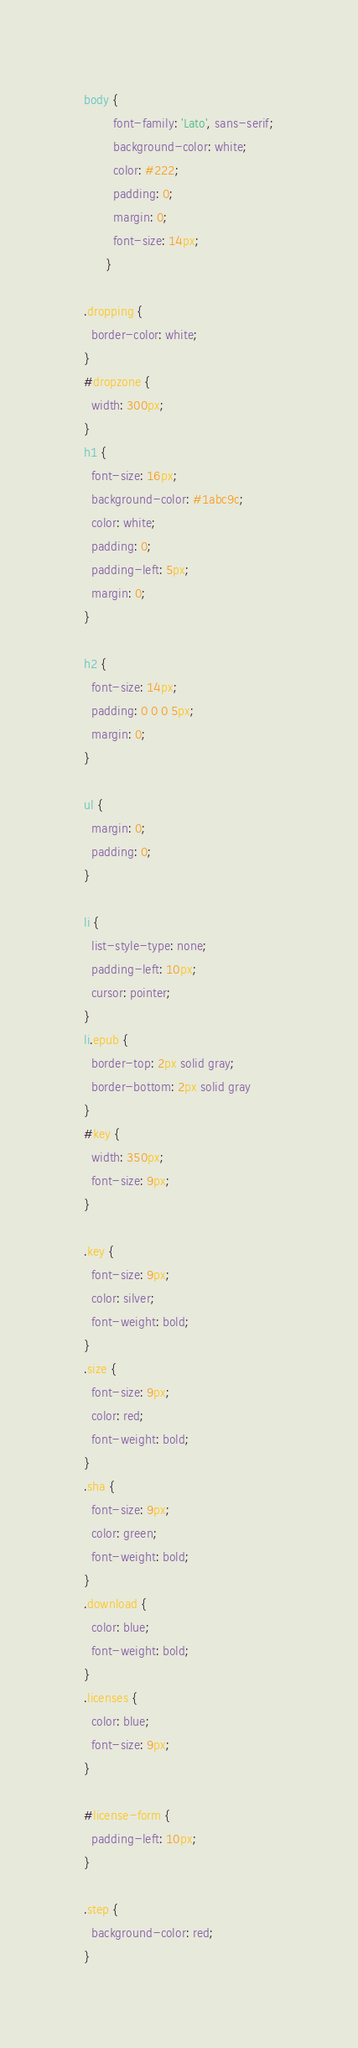<code> <loc_0><loc_0><loc_500><loc_500><_CSS_>body {
        font-family: 'Lato', sans-serif;
        background-color: white;
        color: #222;
        padding: 0;
        margin: 0;
        font-size: 14px;
      }

.dropping {
  border-color: white;
}
#dropzone {
  width: 300px;
}
h1 {
  font-size: 16px;
  background-color: #1abc9c;
  color: white;
  padding: 0;
  padding-left: 5px;
  margin: 0;
}

h2 {
  font-size: 14px;
  padding: 0 0 0 5px;
  margin: 0;
}

ul {
  margin: 0;
  padding: 0;
}

li {
  list-style-type: none;
  padding-left: 10px;
  cursor: pointer;
}
li.epub {
  border-top: 2px solid gray;
  border-bottom: 2px solid gray
}
#key {
  width: 350px;
  font-size: 9px;
}

.key {
  font-size: 9px;
  color: silver;
  font-weight: bold;
}
.size {
  font-size: 9px;
  color: red;
  font-weight: bold;
}
.sha {
  font-size: 9px;
  color: green;
  font-weight: bold;
}
.download {
  color: blue;
  font-weight: bold;
}
.licenses {
  color: blue;
  font-size: 9px;
}

#license-form {
  padding-left: 10px;
}

.step {
  background-color: red;
}</code> 